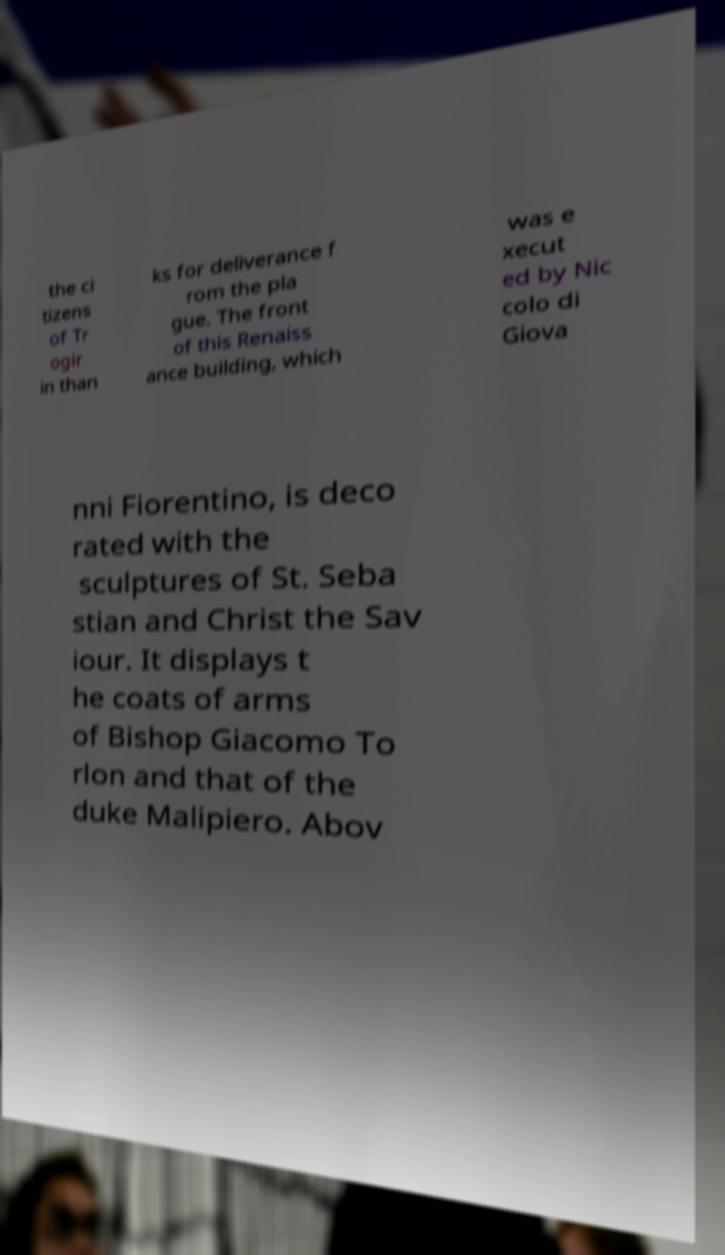There's text embedded in this image that I need extracted. Can you transcribe it verbatim? the ci tizens of Tr ogir in than ks for deliverance f rom the pla gue. The front of this Renaiss ance building, which was e xecut ed by Nic colo di Giova nni Fiorentino, is deco rated with the sculptures of St. Seba stian and Christ the Sav iour. It displays t he coats of arms of Bishop Giacomo To rlon and that of the duke Malipiero. Abov 